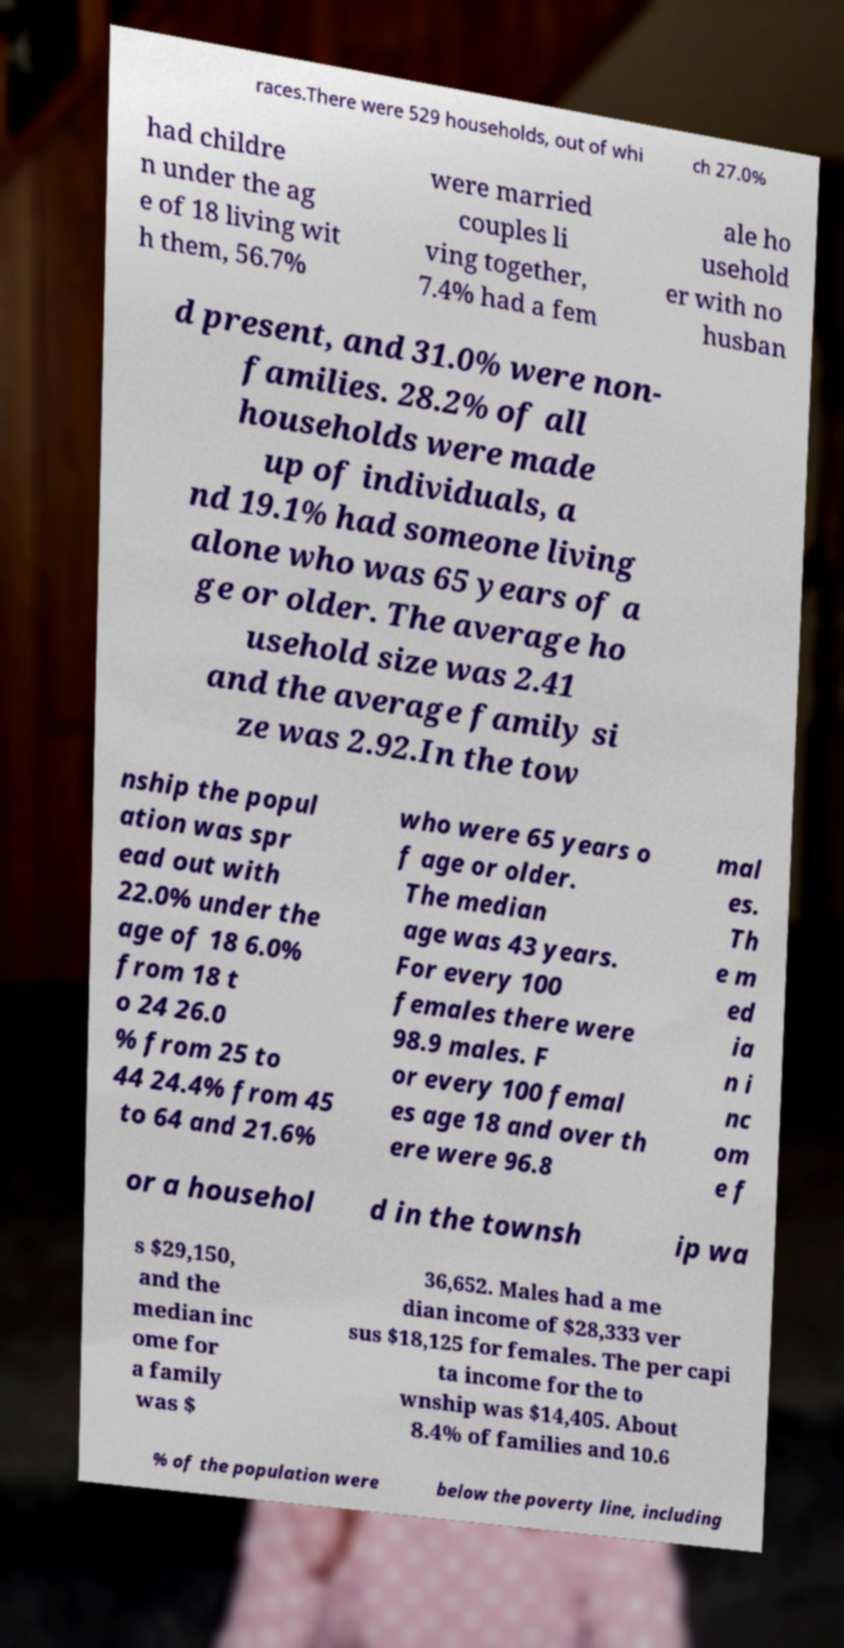For documentation purposes, I need the text within this image transcribed. Could you provide that? races.There were 529 households, out of whi ch 27.0% had childre n under the ag e of 18 living wit h them, 56.7% were married couples li ving together, 7.4% had a fem ale ho usehold er with no husban d present, and 31.0% were non- families. 28.2% of all households were made up of individuals, a nd 19.1% had someone living alone who was 65 years of a ge or older. The average ho usehold size was 2.41 and the average family si ze was 2.92.In the tow nship the popul ation was spr ead out with 22.0% under the age of 18 6.0% from 18 t o 24 26.0 % from 25 to 44 24.4% from 45 to 64 and 21.6% who were 65 years o f age or older. The median age was 43 years. For every 100 females there were 98.9 males. F or every 100 femal es age 18 and over th ere were 96.8 mal es. Th e m ed ia n i nc om e f or a househol d in the townsh ip wa s $29,150, and the median inc ome for a family was $ 36,652. Males had a me dian income of $28,333 ver sus $18,125 for females. The per capi ta income for the to wnship was $14,405. About 8.4% of families and 10.6 % of the population were below the poverty line, including 